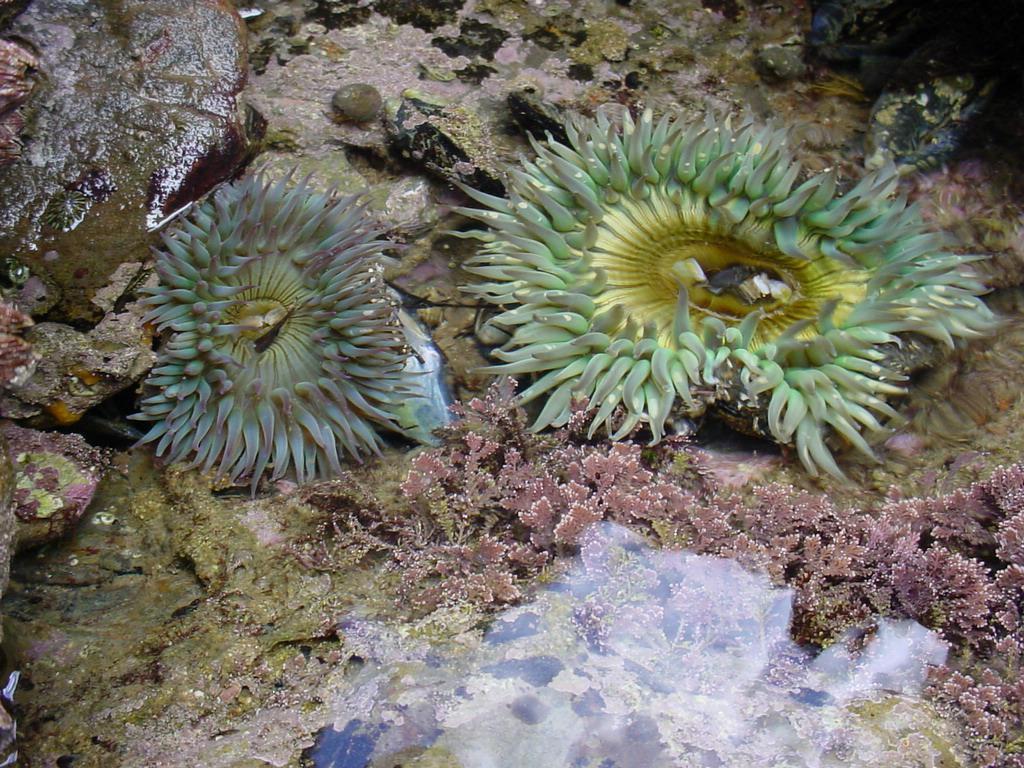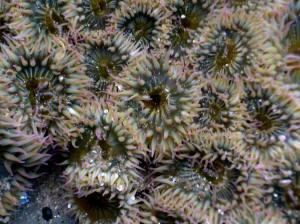The first image is the image on the left, the second image is the image on the right. For the images shown, is this caption "There is exactly one sea anemone in the right image." true? Answer yes or no. No. 